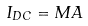Convert formula to latex. <formula><loc_0><loc_0><loc_500><loc_500>I _ { D C } = M A</formula> 